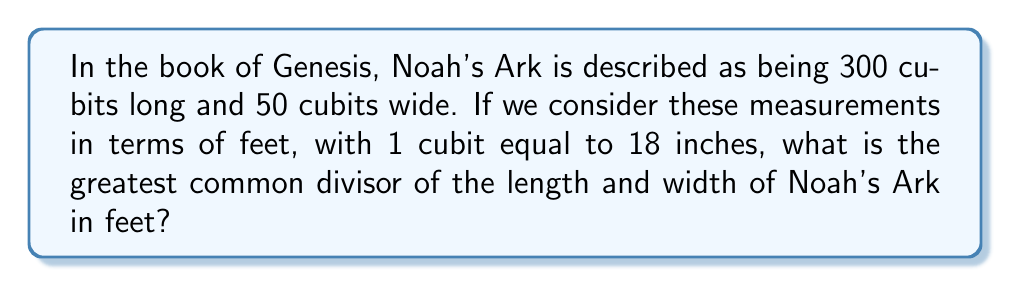Show me your answer to this math problem. Let's approach this step-by-step:

1) First, we need to convert the measurements from cubits to feet:

   Length: $300 \text{ cubits} = 300 \times \frac{18}{12} = 450 \text{ feet}$
   Width: $50 \text{ cubits} = 50 \times \frac{18}{12} = 75 \text{ feet}$

2) Now we need to find the greatest common divisor (GCD) of 450 and 75.

3) We can use the Euclidean algorithm:
   
   $450 = 6 \times 75 + 0$

4) Since the remainder is 0, the GCD is 75.

5) To verify, let's factor both numbers:
   
   $450 = 2 \times 3^2 \times 5^2$
   $75 = 3 \times 5^2$

6) The greatest common divisor indeed includes all the shared factors: $3 \times 5^2 = 75$

Therefore, the greatest common divisor of the length and width of Noah's Ark in feet is 75.
Answer: 75 